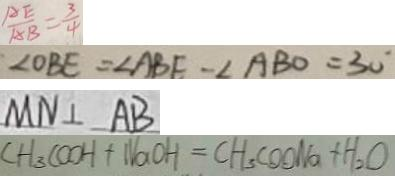Convert formula to latex. <formula><loc_0><loc_0><loc_500><loc_500>\frac { A E } { A B } = \frac { 3 } { 4 } 
 \angle O B E = \angle A B E - \angle A B O = 3 0 ^ { \circ } 
 M N \bot A B 
 C H _ { 3 } C O O H + N a O H = C H _ { 3 } C O O N a + H _ { 2 } O</formula> 